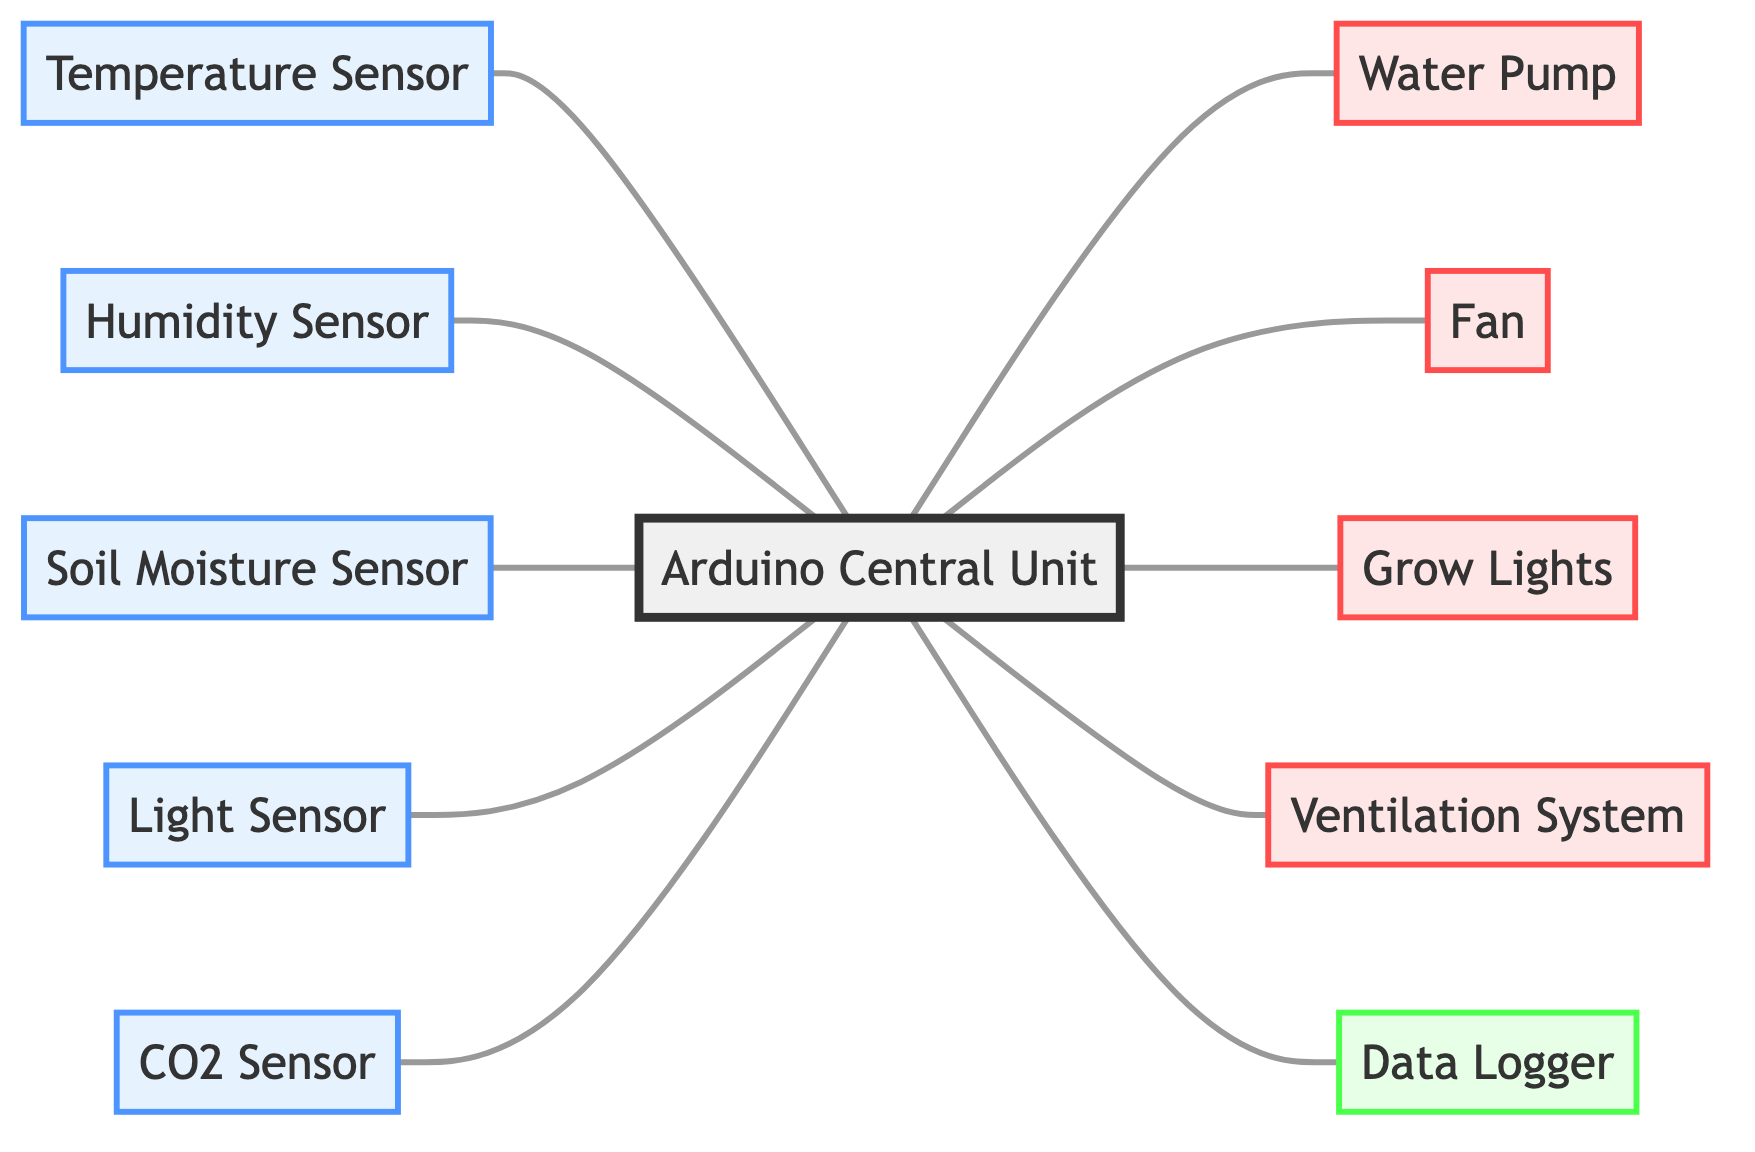What is the central unit in the diagram? The diagram's central unit is labeled as "Arduino Central Unit," which acts as the main controller for the interdependencies of various sensors and actuators.
Answer: Arduino Central Unit How many sensors are connected to the Arduino Central Unit? There are five sensors shown in the diagram that connect to the Arduino Central Unit: Temperature Sensor, Humidity Sensor, Soil Moisture Sensor, Light Sensor, and CO2 Sensor.
Answer: Five sensors Which actuator is responsible for managing water in the system? The actuator responsible for managing water is labeled as "Water Pump," which is directly controlled by the Arduino Central Unit for irrigation purposes.
Answer: Water Pump What is the relationship between the Fan and the Arduino Central Unit? The relationship is that the Fan is controlled by the Arduino Central Unit, which indicates that the central unit sends commands to manage the Fan's operation based on environmental factors.
Answer: Control How many edges are there total in the diagram? The total number of edges in the diagram is ten, representing the connections between the Arduino Central Unit, the sensors, and the actuators.
Answer: Ten edges Which device logs data from the sensors? The device that logs data from the sensors is labeled as "Data Logger," receiving information from the Arduino Central Unit to keep track of the greenhouse's environmental conditions.
Answer: Data Logger What do the Light Sensor and Grow Lights have in common? Both the Light Sensor and Grow Lights are directly connected to the Arduino Central Unit, indicating interdependencies where the Light Sensor provides data to inform the operation of the Grow Lights.
Answer: Direct connection Which two actuators are primarily used for climate control? The two actuators primarily used for climate control are the Fan and the Ventilation System, both receiving control signals from the Arduino Central Unit to maintain optimal conditions.
Answer: Fan and Ventilation System What type of graph represents the interdependencies in the diagram? The interdependencies in this diagram are represented as an Undirected Graph, showing connections without directionality between nodes such as sensors and actuators.
Answer: Undirected Graph 